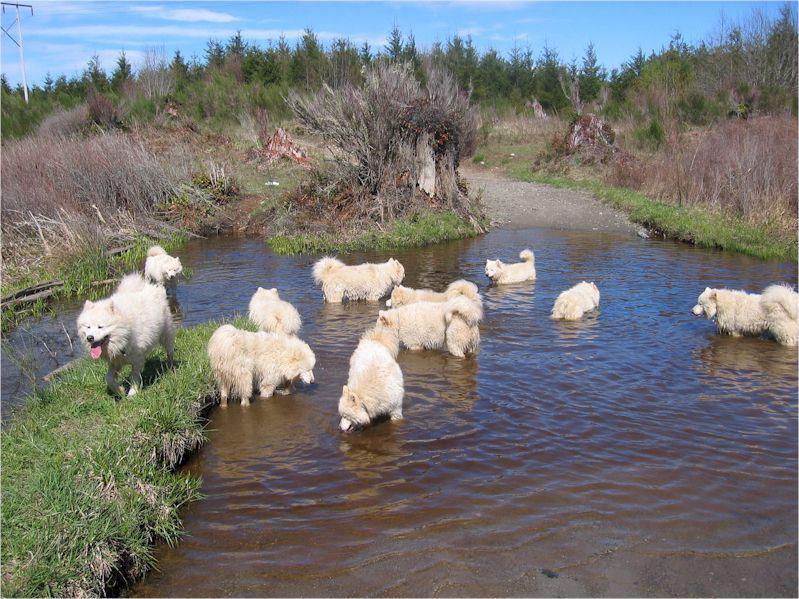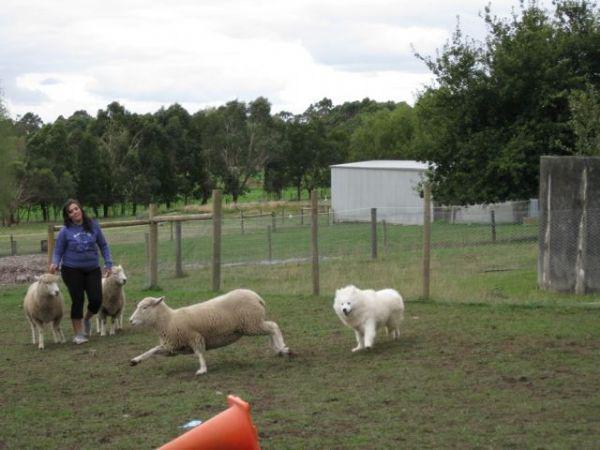The first image is the image on the left, the second image is the image on the right. Considering the images on both sides, is "In one image, a woman is shown with a white dog and three sheep." valid? Answer yes or no. Yes. The first image is the image on the left, the second image is the image on the right. Examine the images to the left and right. Is the description "At least one image shows a person in a vehicle behind at least one dog, going down a lane." accurate? Answer yes or no. No. 